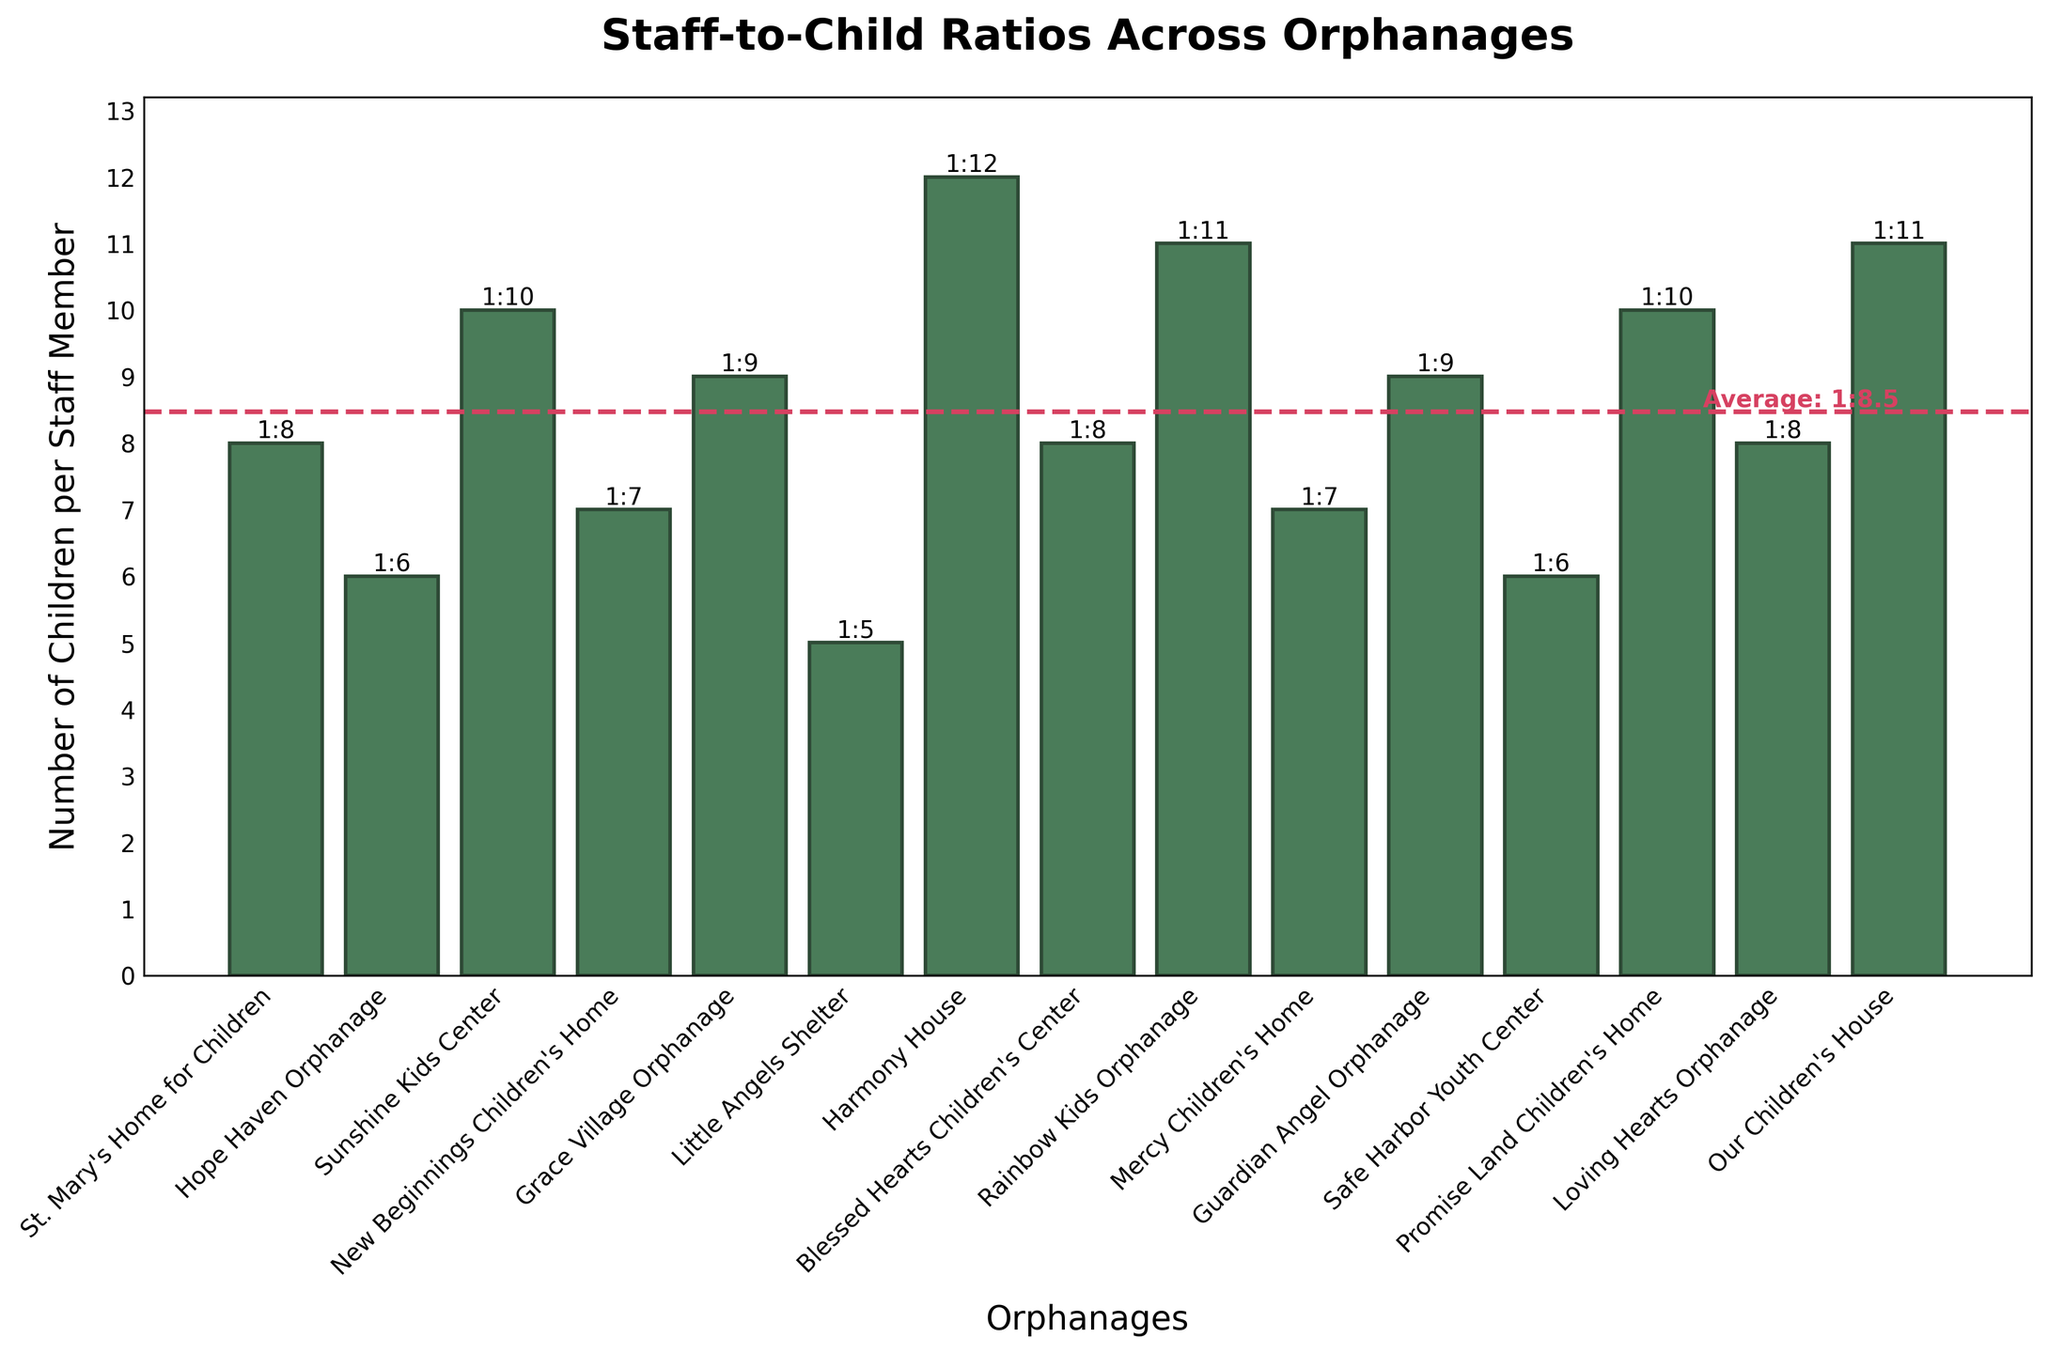Which orphanage has the highest staff-to-child ratio? The column with the highest bar indicates the highest ratio. Harmony House has the highest bar with a 1:12 staff-to-child ratio.
Answer: Harmony House Which orphanages have a staff-to-child ratio lower than the average? The orphanages below the dashed horizontal line represent ratios below the average. Counting, Hope Haven Orphanage, Little Angels Shelter, Safe Harbor Youth Center, and New Beginnings Children's Home are below the average line.
Answer: Hope Haven Orphanage, Little Angels Shelter, Safe Harbor Youth Center, New Beginnings Children's Home How does the ratio of St. Mary's Home for Children compare to Grace Village Orphanage? St. Mary's Home for Children has a staff-to-child ratio of 1:8, while Grace Village Orphanage has a ratio of 1:9. Since 1:8 is better than 1:9, St. Mary's Home for Children has a better ratio.
Answer: St. Mary's Home for Children has a better ratio What is the average staff-to-child ratio across all orphanages? The horizontal dashed line represents the average ratio. It is labeled as approximately 1:8.3.
Answer: 1:8.3 Which orphanage has the lowest staff-to-child ratio? The column with the lowest bar indicates the lowest ratio. Little Angels Shelter has the lowest bar with a 1:5 staff-to-child ratio.
Answer: Little Angels Shelter How many orphanages have a 1:8 staff-to-child ratio? By counting the bars that are labeled with 1:8, we find that there are three such orphanages.
Answer: 3 Are there more orphanages with a staff-to-child ratio greater than or less than 1:10? Identify the number of bars above and below the 1:10 mark. There are more bars below 1:10 (10) than above 1:10 (4).
Answer: Less than 1:10 Which orphanage has a staff-to-child ratio equal to the average ratio in the region? Since the average ratio is approximately 1:8.3, check if there's a bar exactly at this point. No orphanage has exactly this ratio.
Answer: None How much lower is the staff-to-child ratio of Little Angels Shelter compared to Harmony House? Subtract the ratio of Harmony House (1:12) from Little Angels Shelter (1:5). So, 12 - 5 = 7.
Answer: 7 Which two orphanages have a staff-to-child ratio of 1:7? Counting bars with 1:7 ratios, we find New Beginnings Children's Home and Mercy Children's Home.
Answer: New Beginnings Children's Home, Mercy Children's Home 